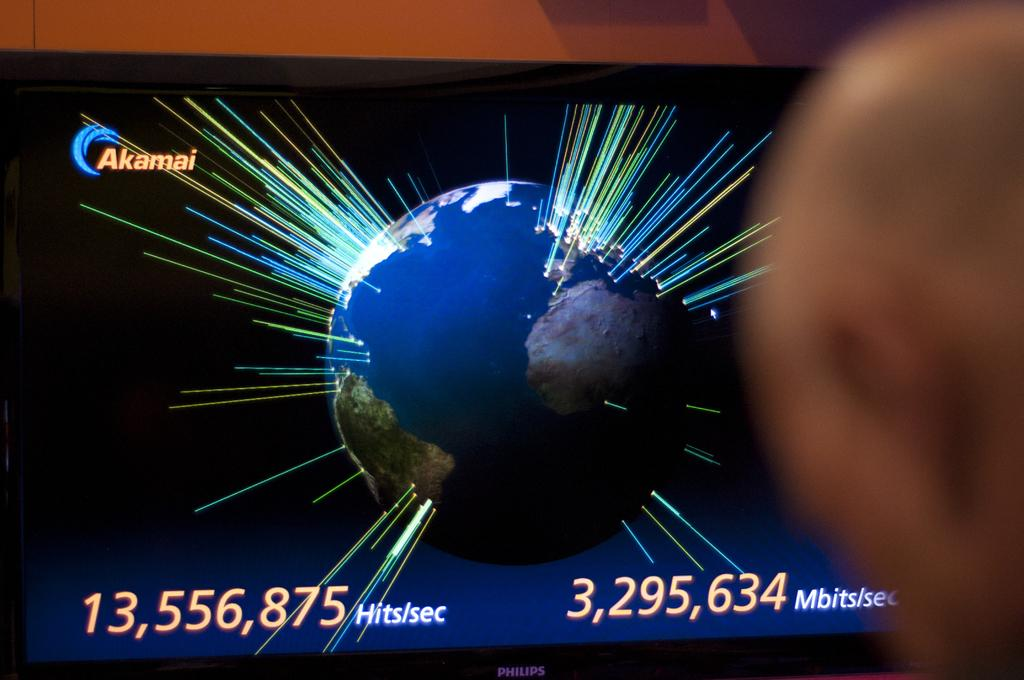What is the main object in the image? There is a television in the image. What is displayed on the television screen? The television screen displays an image of the Earth. Are there any additional details on the screen? Yes, there are numbers written on the screen. What else can be seen in the image besides the television? There are colorful rays visible in the image. Where is the ant located in the image? There is no ant present in the image. What type of doll is being exchanged on the television screen? There is no doll or exchange depicted on the television screen; it displays an image of the Earth and numbers. 